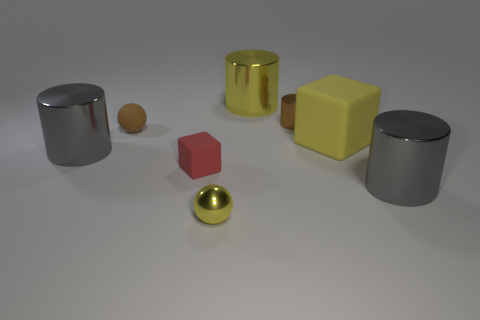Is the number of tiny metallic cylinders that are left of the small yellow metallic object less than the number of small purple cubes?
Give a very brief answer. No. Is the number of gray things in front of the big yellow matte object greater than the number of big gray cylinders that are to the right of the small brown rubber thing?
Give a very brief answer. Yes. Are there any other things that are the same color as the metal sphere?
Provide a succinct answer. Yes. There is a big yellow thing that is right of the small shiny cylinder; what is its material?
Ensure brevity in your answer.  Rubber. Is the size of the brown rubber ball the same as the yellow matte block?
Provide a short and direct response. No. What number of other objects are the same size as the yellow matte thing?
Offer a very short reply. 3. Do the big matte block and the small metallic sphere have the same color?
Provide a short and direct response. Yes. There is a big gray object right of the small yellow object that is in front of the tiny ball behind the big cube; what is its shape?
Your answer should be very brief. Cylinder. How many objects are large yellow things to the right of the brown shiny cylinder or brown shiny cylinders to the left of the yellow matte thing?
Provide a succinct answer. 2. How big is the gray thing that is on the right side of the cylinder that is left of the small red block?
Keep it short and to the point. Large. 